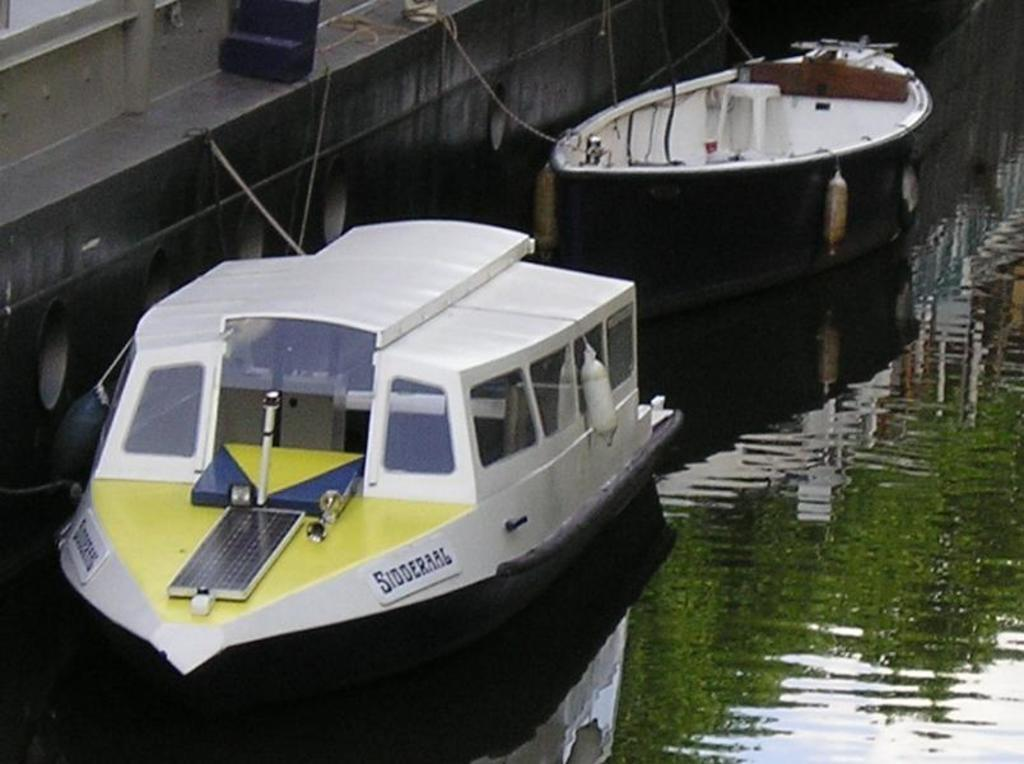What is the primary element in the image? There is water in the image. What type of objects are present in the water? There are boats with ropes in the image. What structure can be seen in the image? There is a wall in the image. What color is the object located at the top side of the image? There is a black color object in the top side of the image. How many bells can be heard ringing in the image? There are no bells present in the image, so it is not possible to hear them ringing. 